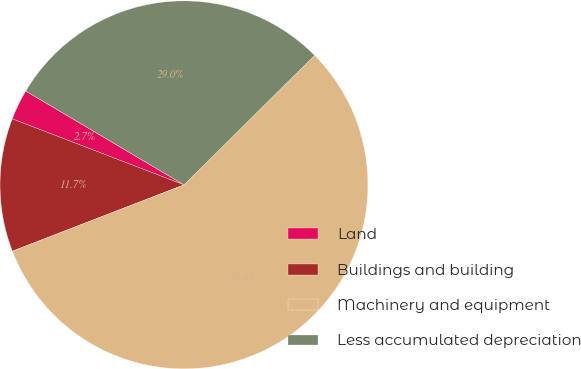<chart> <loc_0><loc_0><loc_500><loc_500><pie_chart><fcel>Land<fcel>Buildings and building<fcel>Machinery and equipment<fcel>Less accumulated depreciation<nl><fcel>2.68%<fcel>11.71%<fcel>56.56%<fcel>29.05%<nl></chart> 